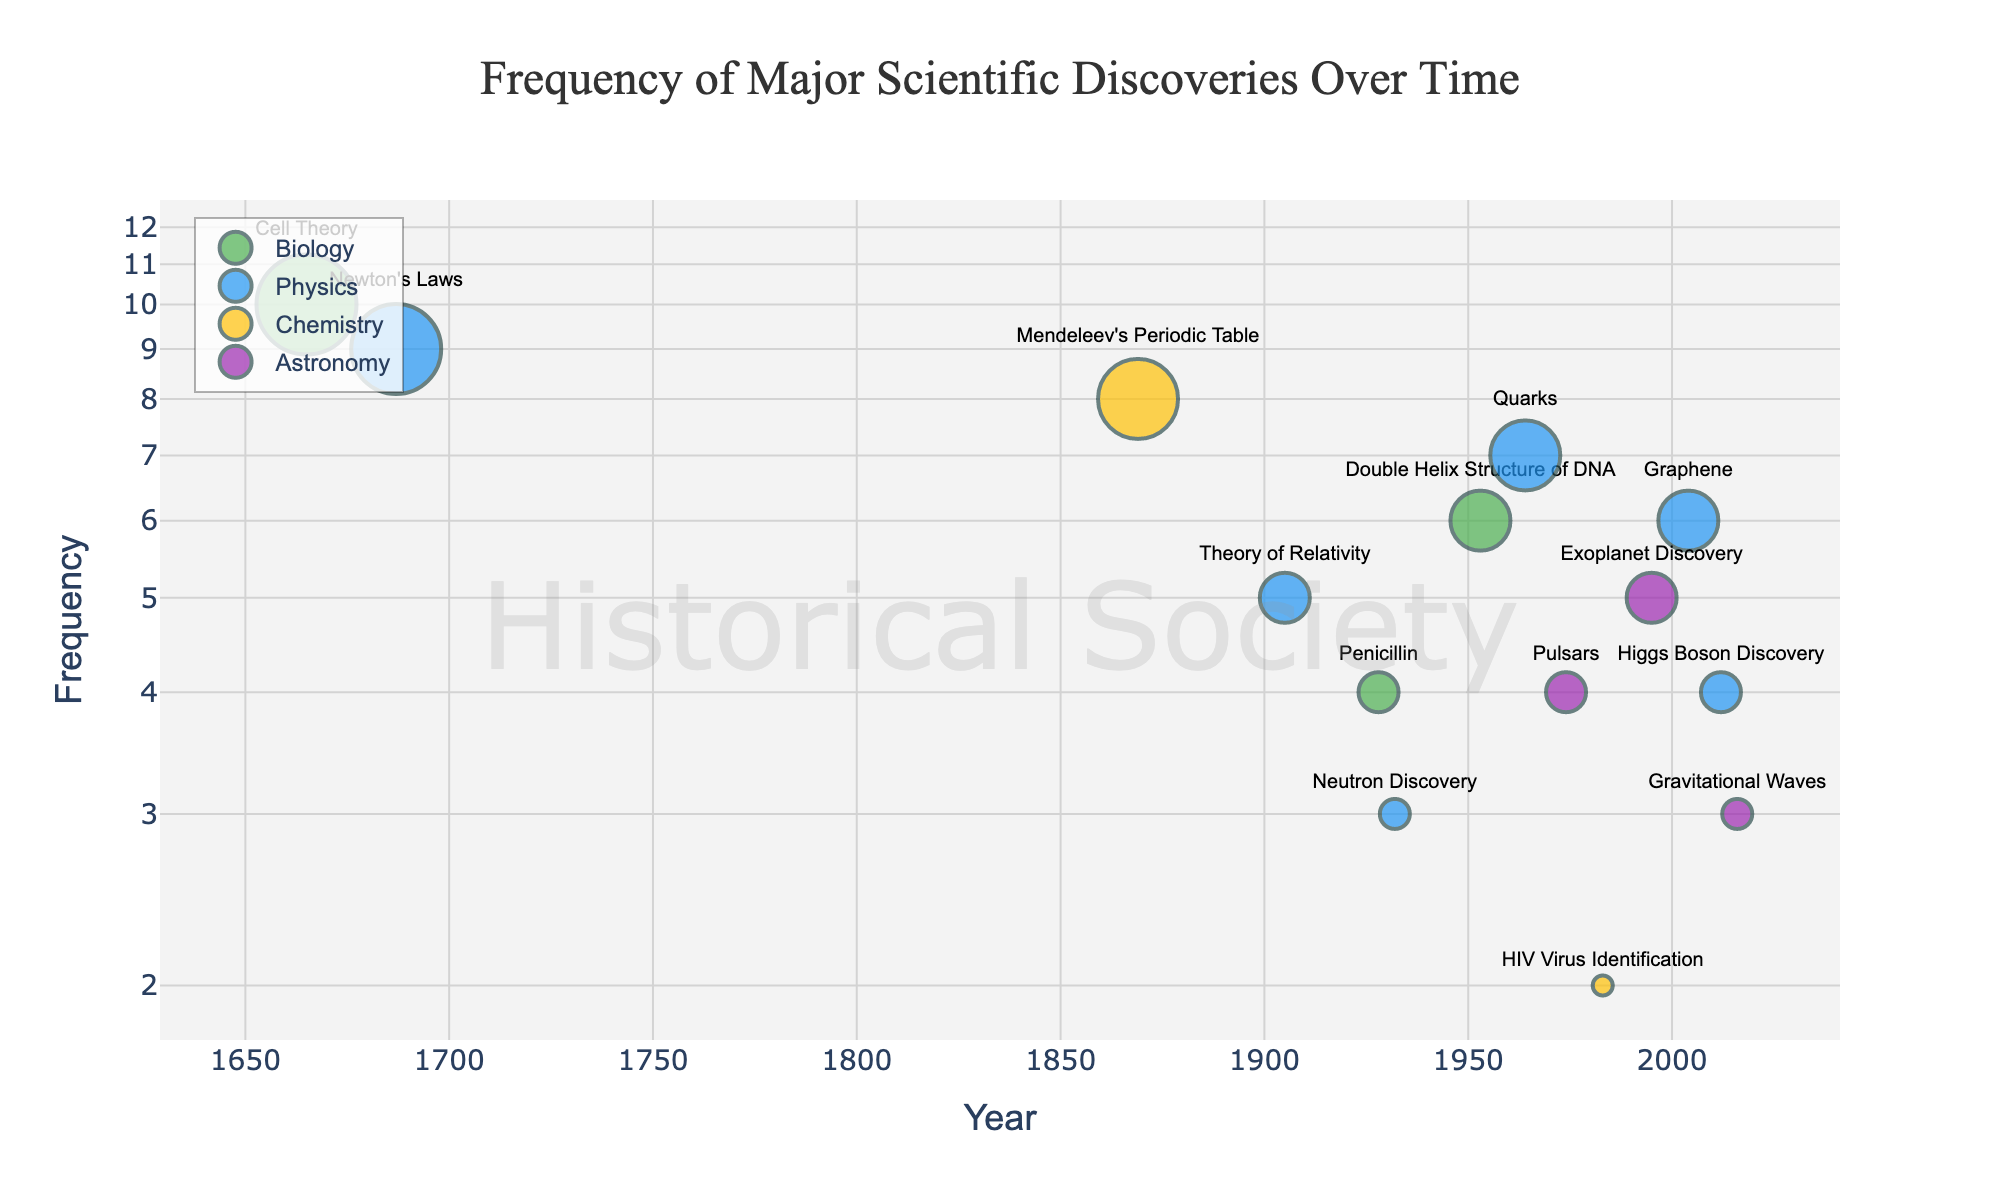What scientific discovery in Physics had the highest frequency? The Physics discovery with the highest frequency can be identified by looking at the markers for Physics (colored dark blue) and finding the one with the largest value on the y-axis. Newton's Laws in 1687 has the highest frequency among the Physics discoveries.
Answer: Newton's Laws How many discoveries in Biology are plotted in the figure? Count the number of green markers which represent the different Biology discoveries. There are three: Cell Theory, Penicillin, and the Double Helix Structure of DNA.
Answer: 3 Which field has the most recent discovery, and what is it? Examine the x-axis (Year) and look for the right-most marker for each field. The most recent discovery is in Astronomy, corresponding to the discovery of Gravitational Waves in 2016.
Answer: Astronomy, Gravitational Waves Compare the frequency of the Theory of Relativity in Physics with that of Mendeleev's Periodic Table in Chemistry. Which one is higher? Locate the markers for the Theory of Relativity and Mendeleev's Periodic Table, then compare their y-values. The y-value for Mendeleev's Periodic Table (8) is higher than that for the Theory of Relativity (5).
Answer: Mendeleev's Periodic Table What is the average frequency of the discoveries in Chemistry? There are two Chemistry discoveries: Mendeleev’s Periodic Table (8) and HIV Virus Identification (2). Sum these frequencies (8 + 2 = 10) and then divide by the number of discoveries (2).
Answer: 5 Which field has the least frequent discovery and what is it? To find the field with the least frequent discovery, identify the discovery with the smallest y-axis value (Frequency). The HIV Virus Identification in Chemistry has a frequency of 2, which is the lowest.
Answer: Chemistry, HIV Virus Identification What is the general trend of discoveries in Physics over time? Count the number of Physics markers from left to right and observe their y-values. Over time, the frequencies of Physics discoveries generally decrease, suggesting fewer major discoveries are recognized later in time.
Answer: Decreasing frequency over time Identify the discovery with a frequency of 4 and specify their fields and years. Find the markers along the y-axis that correspond to a frequency of 4. The discoveries are Penicillin (Biology, 1928), Pulsars (Astronomy, 1974), and Higgs Boson Discovery (Physics, 2012).
Answer: Penicillin (Biology, 1928); Pulsars (Astronomy, 1974); Higgs Boson Discovery (Physics, 2012) What is the median frequency of Biology discoveries? The frequencies of Biology discoveries are 10 (Cell Theory), 4 (Penicillin), and 6 (Double Helix Structure of DNA). Arrange them in ascending order: 4, 6, 10. The median value is the middle value, which is 6.
Answer: 6 